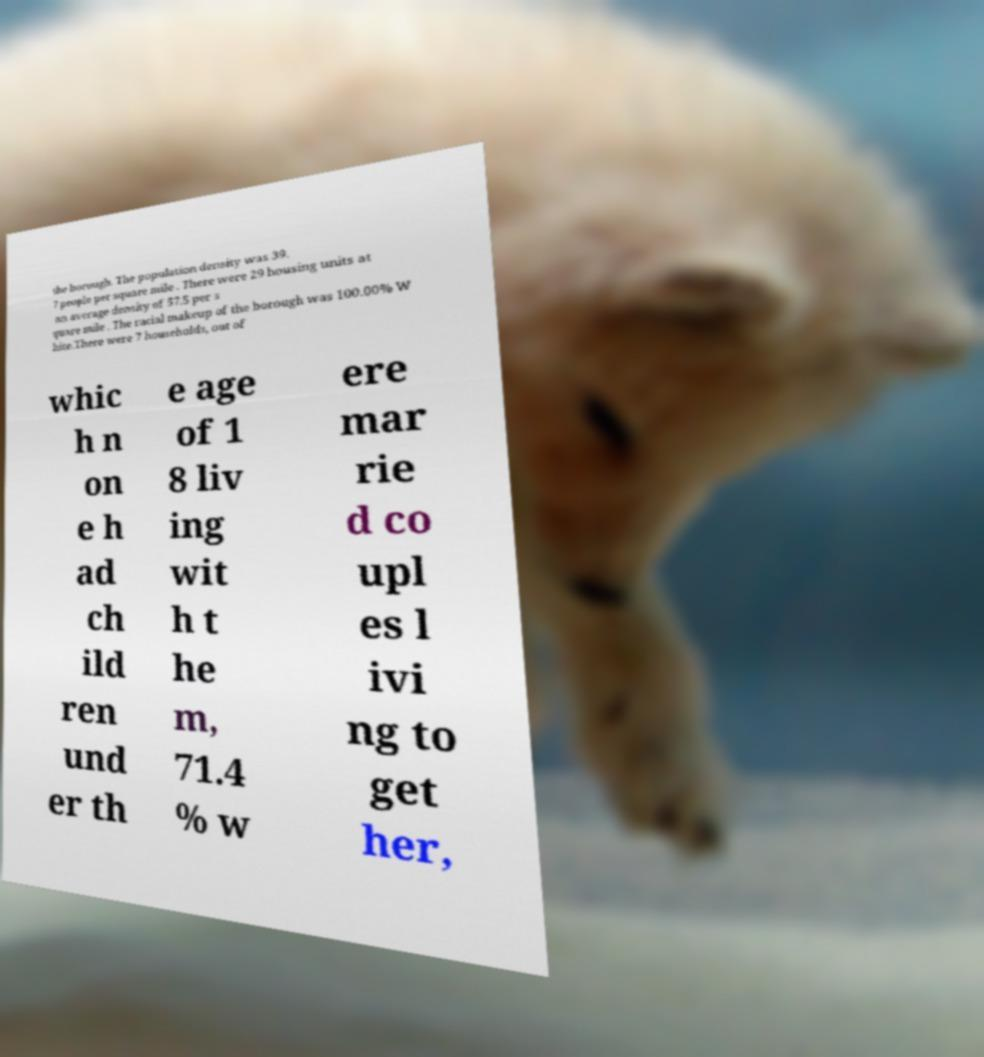For documentation purposes, I need the text within this image transcribed. Could you provide that? the borough. The population density was 39. 7 people per square mile . There were 29 housing units at an average density of 57.5 per s quare mile . The racial makeup of the borough was 100.00% W hite.There were 7 households, out of whic h n on e h ad ch ild ren und er th e age of 1 8 liv ing wit h t he m, 71.4 % w ere mar rie d co upl es l ivi ng to get her, 